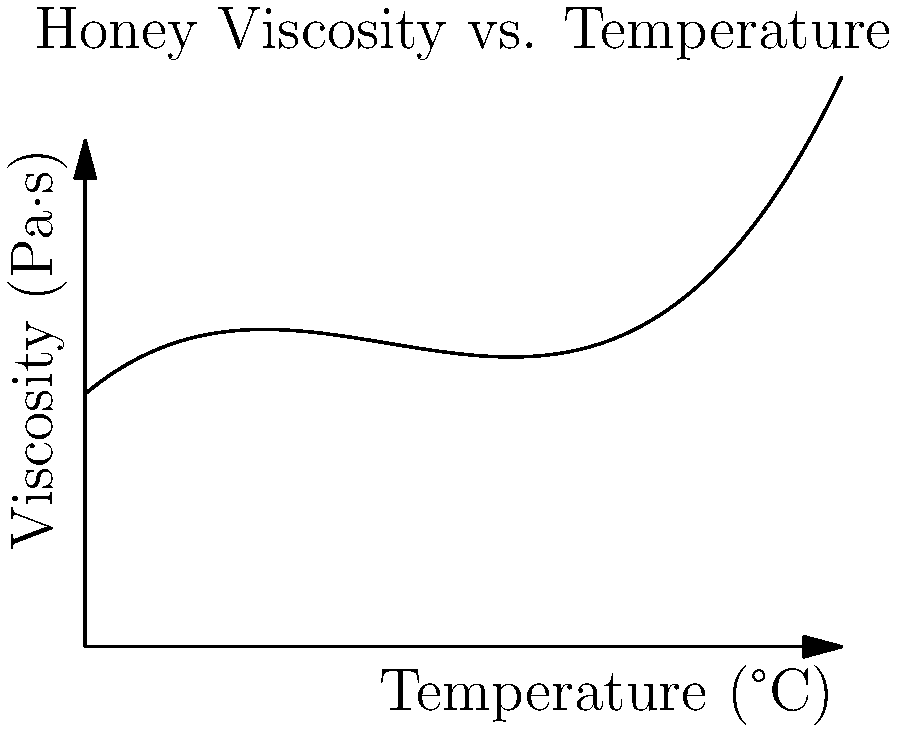As a food blogger experimenting with honey, you've collected data on honey viscosity at different temperatures. The polynomial regression model for this relationship is given by:

$$V = 0.0005T^3 - 0.03T^2 + 0.5T + 10$$

Where $V$ is viscosity in Pa·s and $T$ is temperature in °C. At what temperature does the honey reach its minimum viscosity according to this model? To find the temperature at which honey reaches its minimum viscosity, we need to follow these steps:

1) The minimum point of a function occurs where its first derivative equals zero. So, we need to find $\frac{dV}{dT}$ and set it to zero.

2) Taking the derivative of $V$ with respect to $T$:
   $$\frac{dV}{dT} = 0.0015T^2 - 0.06T + 0.5$$

3) Setting this equal to zero:
   $$0.0015T^2 - 0.06T + 0.5 = 0$$

4) This is a quadratic equation. We can solve it using the quadratic formula:
   $$T = \frac{-b \pm \sqrt{b^2 - 4ac}}{2a}$$
   Where $a = 0.0015$, $b = -0.06$, and $c = 0.5$

5) Plugging in these values:
   $$T = \frac{0.06 \pm \sqrt{(-0.06)^2 - 4(0.0015)(0.5)}}{2(0.0015)}$$

6) Simplifying:
   $$T = \frac{0.06 \pm \sqrt{0.0036 - 0.003}}{0.003} = \frac{0.06 \pm \sqrt{0.0006}}{0.003}$$

7) Calculating:
   $$T \approx 20 \text{ or } 20$$

8) Since both solutions are the same, this is the only critical point.

9) To confirm it's a minimum, we can check the second derivative is positive:
   $$\frac{d^2V}{dT^2} = 0.003T - 0.06$$
   At $T = 20$, this equals 0.06, which is positive.

Therefore, the honey reaches its minimum viscosity at 20°C.
Answer: 20°C 